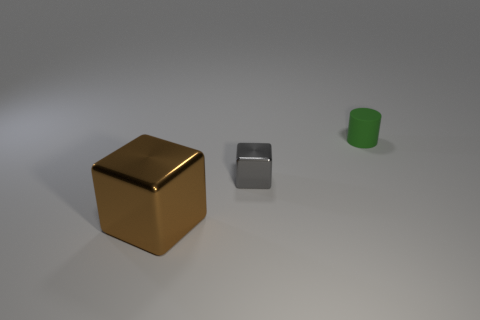What number of other tiny things have the same shape as the gray metallic object?
Keep it short and to the point. 0. What is the cylinder made of?
Your answer should be compact. Rubber. Is the number of big things in front of the big brown block the same as the number of large brown rubber spheres?
Ensure brevity in your answer.  Yes. What shape is the other matte thing that is the same size as the gray object?
Your response must be concise. Cylinder. There is a small metal cube to the right of the brown object; are there any things that are in front of it?
Provide a short and direct response. Yes. How many big things are either red metallic objects or cylinders?
Ensure brevity in your answer.  0. Is there a green object that has the same size as the gray object?
Give a very brief answer. Yes. What number of metal objects are either big brown things or large cyan spheres?
Give a very brief answer. 1. How many small blue cubes are there?
Your answer should be compact. 0. Is the material of the cube behind the large brown cube the same as the thing that is to the right of the gray metallic thing?
Provide a short and direct response. No. 